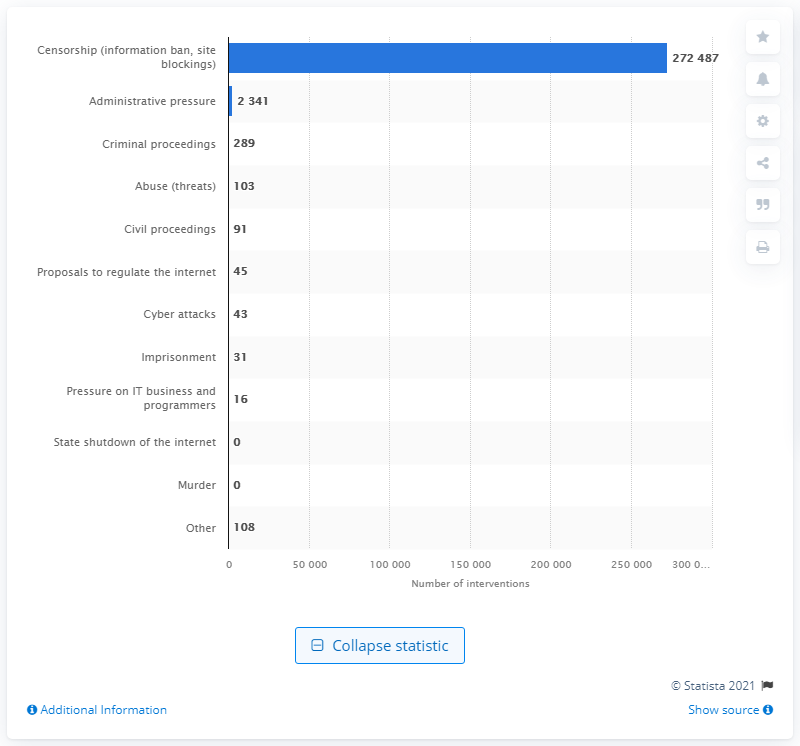List a handful of essential elements in this visual. In 2020, Russian state authorities blocked a significant number of websites, with the exact number being 272,487. 